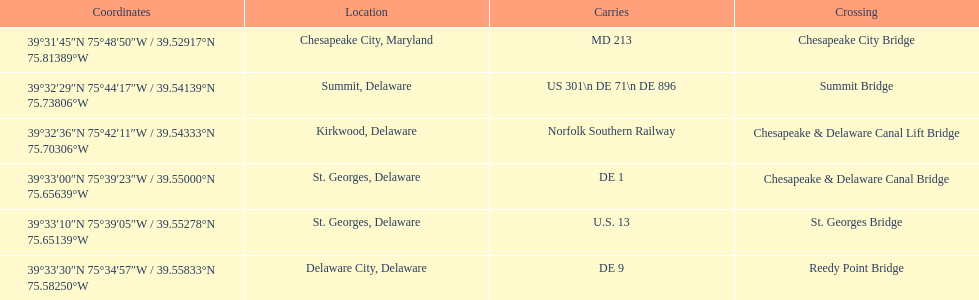How many crossings are in maryland? 1. Could you help me parse every detail presented in this table? {'header': ['Coordinates', 'Location', 'Carries', 'Crossing'], 'rows': [['39°31′45″N 75°48′50″W\ufeff / \ufeff39.52917°N 75.81389°W', 'Chesapeake City, Maryland', 'MD 213', 'Chesapeake City Bridge'], ['39°32′29″N 75°44′17″W\ufeff / \ufeff39.54139°N 75.73806°W', 'Summit, Delaware', 'US 301\\n DE 71\\n DE 896', 'Summit Bridge'], ['39°32′36″N 75°42′11″W\ufeff / \ufeff39.54333°N 75.70306°W', 'Kirkwood, Delaware', 'Norfolk Southern Railway', 'Chesapeake & Delaware Canal Lift Bridge'], ['39°33′00″N 75°39′23″W\ufeff / \ufeff39.55000°N 75.65639°W', 'St.\xa0Georges, Delaware', 'DE 1', 'Chesapeake & Delaware Canal Bridge'], ['39°33′10″N 75°39′05″W\ufeff / \ufeff39.55278°N 75.65139°W', 'St.\xa0Georges, Delaware', 'U.S.\xa013', 'St.\xa0Georges Bridge'], ['39°33′30″N 75°34′57″W\ufeff / \ufeff39.55833°N 75.58250°W', 'Delaware City, Delaware', 'DE\xa09', 'Reedy Point Bridge']]} 